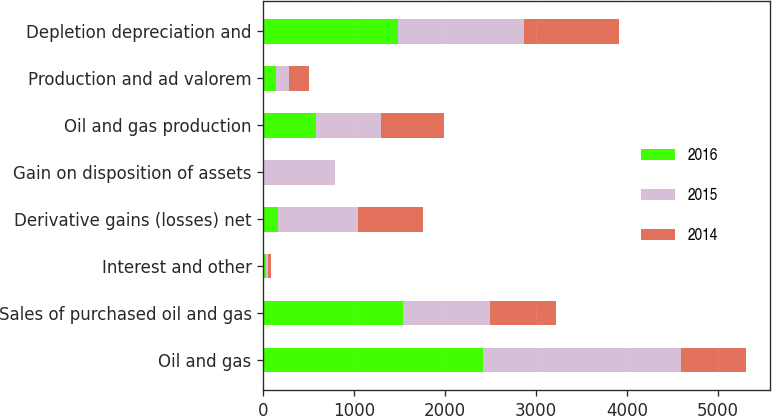Convert chart. <chart><loc_0><loc_0><loc_500><loc_500><stacked_bar_chart><ecel><fcel>Oil and gas<fcel>Sales of purchased oil and gas<fcel>Interest and other<fcel>Derivative gains (losses) net<fcel>Gain on disposition of assets<fcel>Oil and gas production<fcel>Production and ad valorem<fcel>Depletion depreciation and<nl><fcel>2016<fcel>2418<fcel>1533<fcel>32<fcel>161<fcel>2<fcel>581<fcel>136<fcel>1480<nl><fcel>2015<fcel>2178<fcel>964<fcel>22<fcel>879<fcel>782<fcel>717<fcel>145<fcel>1385<nl><fcel>2014<fcel>712<fcel>726<fcel>26<fcel>712<fcel>9<fcel>693<fcel>220<fcel>1047<nl></chart> 